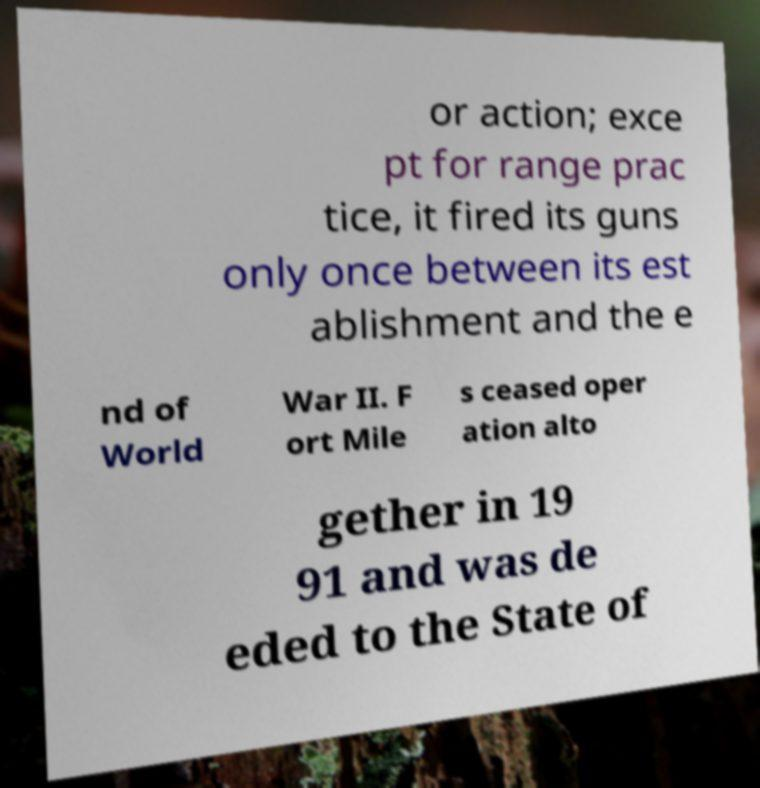Can you read and provide the text displayed in the image?This photo seems to have some interesting text. Can you extract and type it out for me? or action; exce pt for range prac tice, it fired its guns only once between its est ablishment and the e nd of World War II. F ort Mile s ceased oper ation alto gether in 19 91 and was de eded to the State of 